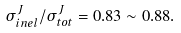<formula> <loc_0><loc_0><loc_500><loc_500>\sigma _ { i n e l } ^ { J } / \sigma _ { t o t } ^ { J } = 0 . 8 3 \sim 0 . 8 8 .</formula> 